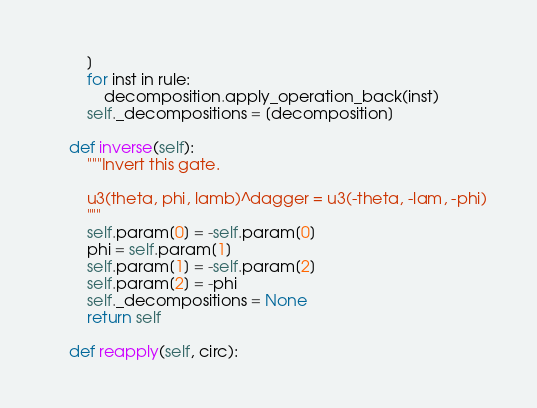<code> <loc_0><loc_0><loc_500><loc_500><_Python_>        ]
        for inst in rule:
            decomposition.apply_operation_back(inst)
        self._decompositions = [decomposition]

    def inverse(self):
        """Invert this gate.

        u3(theta, phi, lamb)^dagger = u3(-theta, -lam, -phi)
        """
        self.param[0] = -self.param[0]
        phi = self.param[1]
        self.param[1] = -self.param[2]
        self.param[2] = -phi
        self._decompositions = None
        return self

    def reapply(self, circ):</code> 